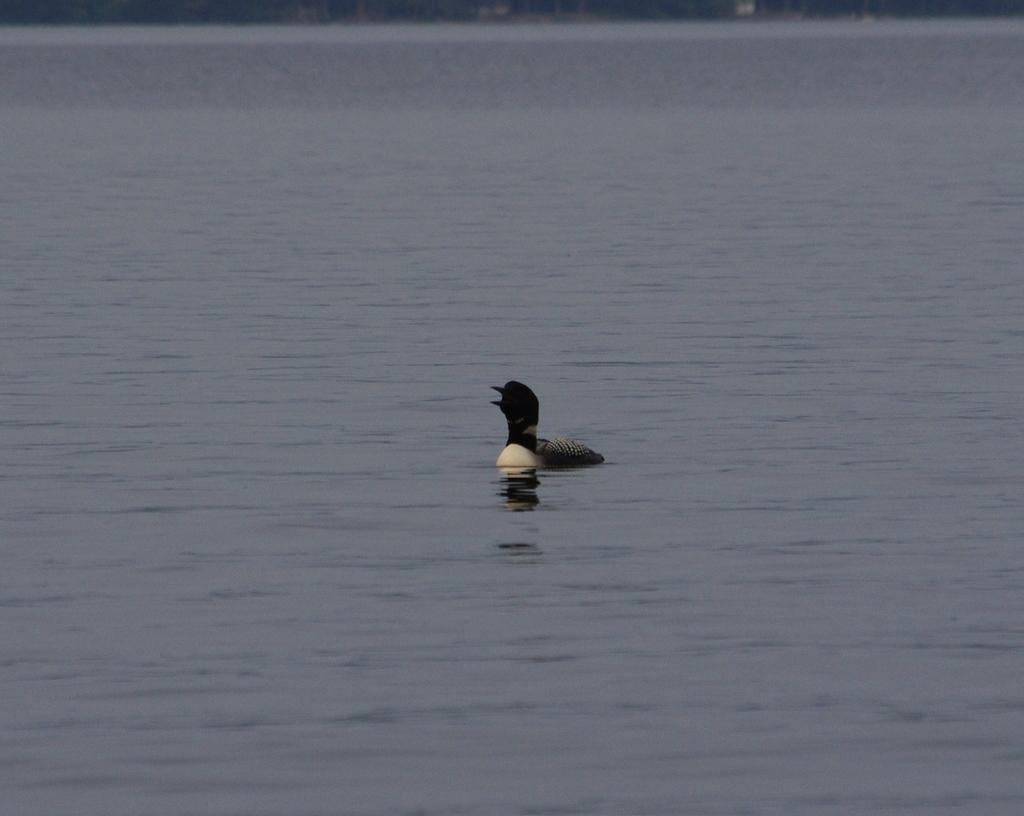Where was the image taken? The image is taken outdoors. What can be seen in the image besides the outdoor setting? There is a river with water in the image. Are there any animals visible in the image? Yes, there is a duck in the river in the image. What type of produce is being harvested by the laborer in the image? There is no laborer or produce present in the image; it features a river with water and a duck. 